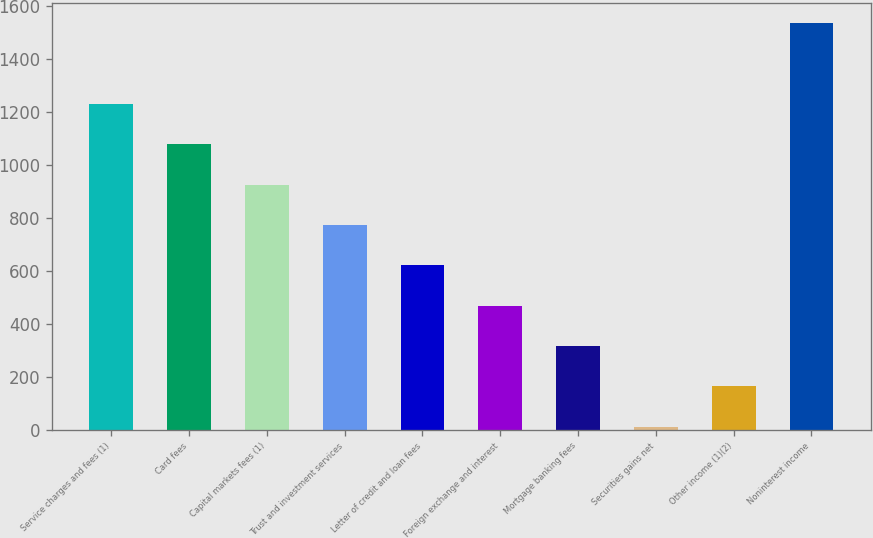Convert chart to OTSL. <chart><loc_0><loc_0><loc_500><loc_500><bar_chart><fcel>Service charges and fees (1)<fcel>Card fees<fcel>Capital markets fees (1)<fcel>Trust and investment services<fcel>Letter of credit and loan fees<fcel>Foreign exchange and interest<fcel>Mortgage banking fees<fcel>Securities gains net<fcel>Other income (1)(2)<fcel>Noninterest income<nl><fcel>1229.4<fcel>1077.1<fcel>924.8<fcel>772.5<fcel>620.2<fcel>467.9<fcel>315.6<fcel>11<fcel>163.3<fcel>1534<nl></chart> 